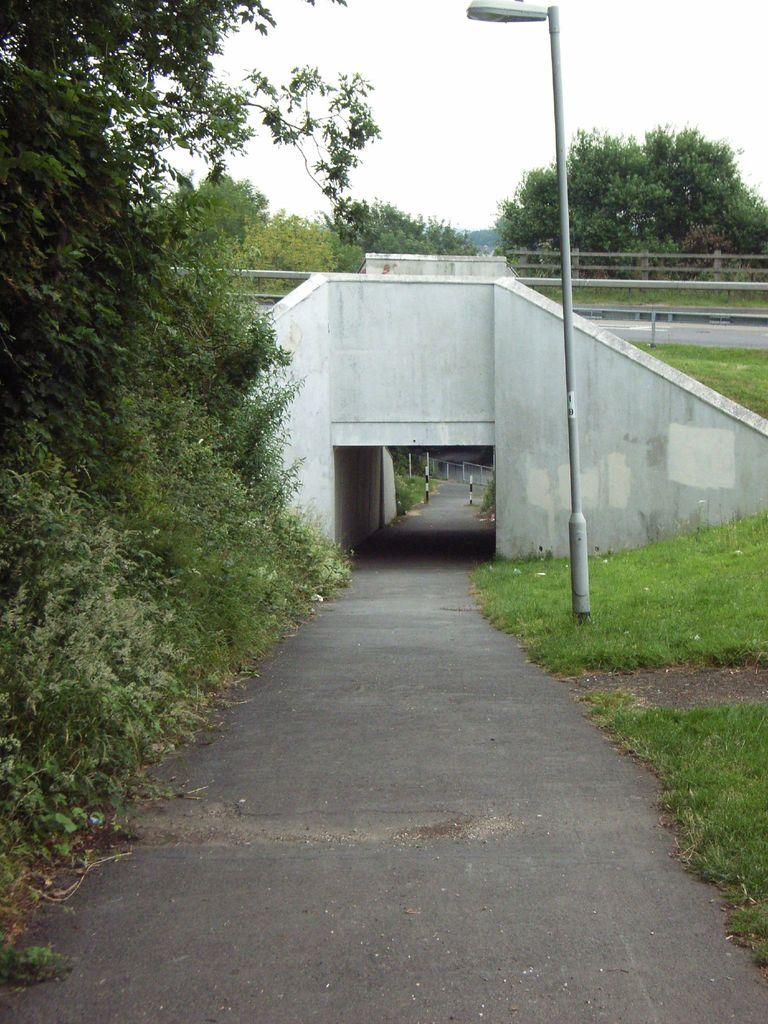What type of structure is present in the image? There is a bridge in the image. What else can be seen in the image besides the bridge? There is a road, an underpass, many plants, grassy land, a street light, and the sky visible in the image. Can you describe the road in the image? The road is present in the image, and it passes through the underpass. What type of vegetation is present in the image? There are many plants and grassy land visible in the image. Who is the owner of the crown in the image? There is no crown present in the image. Can you hear the horn of the vehicle in the image? There is no vehicle or horn present in the image. 